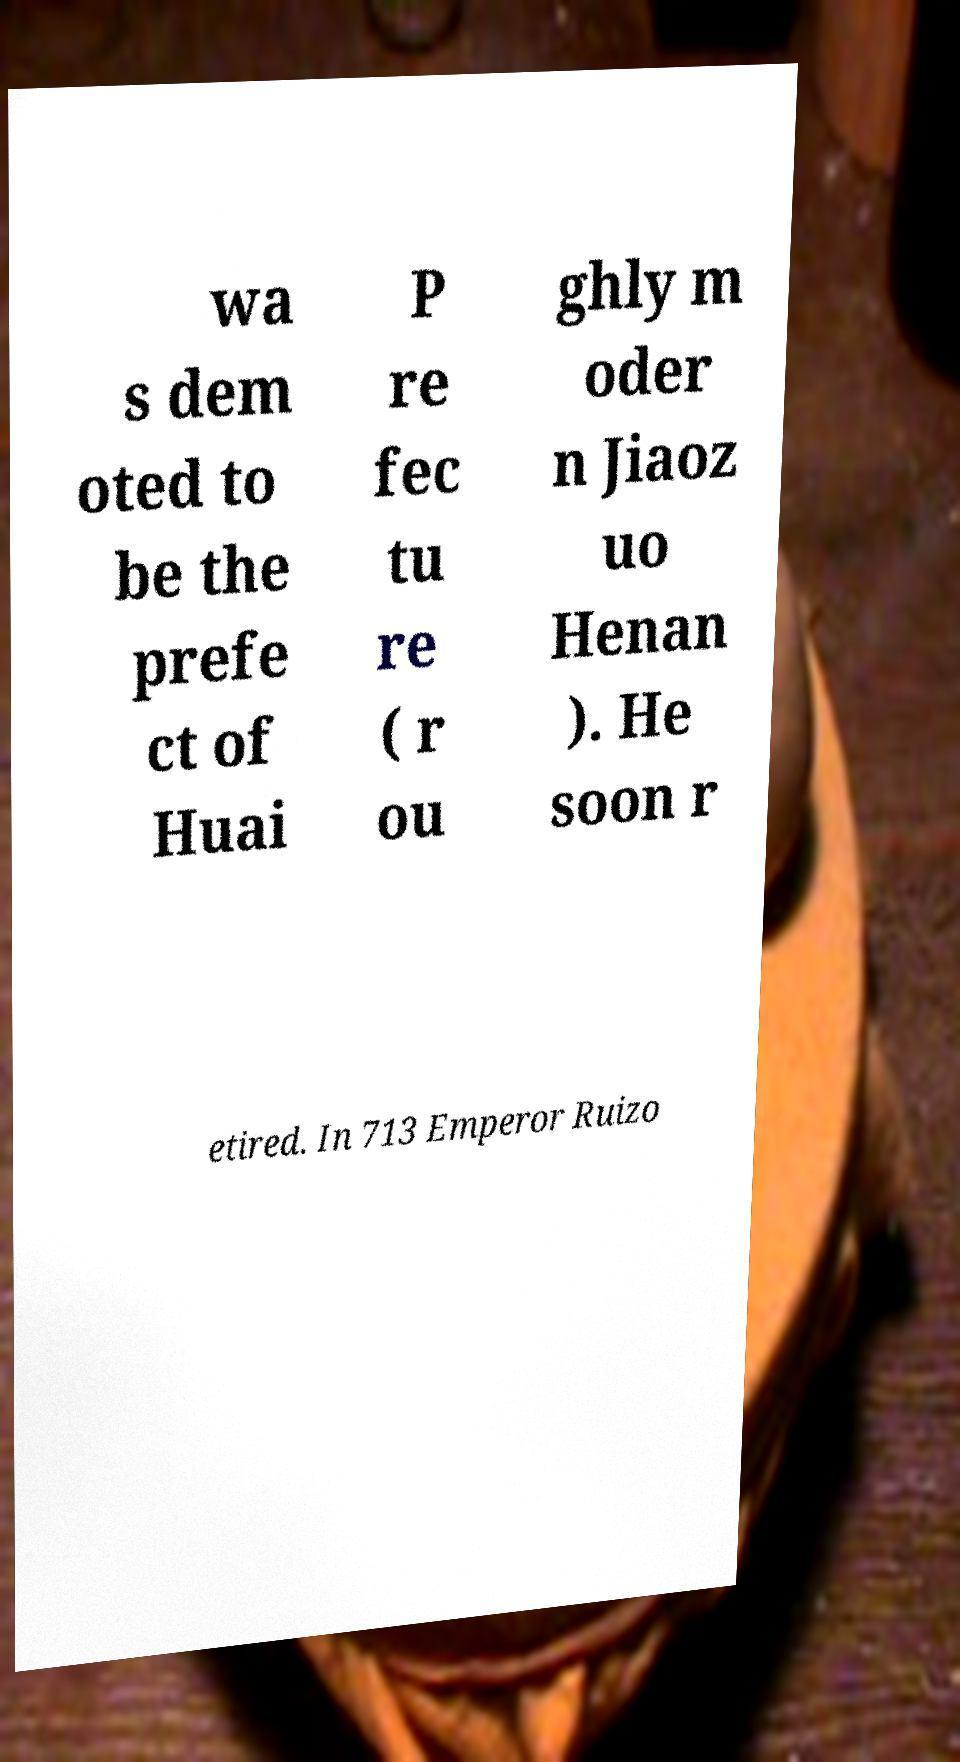Could you assist in decoding the text presented in this image and type it out clearly? wa s dem oted to be the prefe ct of Huai P re fec tu re ( r ou ghly m oder n Jiaoz uo Henan ). He soon r etired. In 713 Emperor Ruizo 